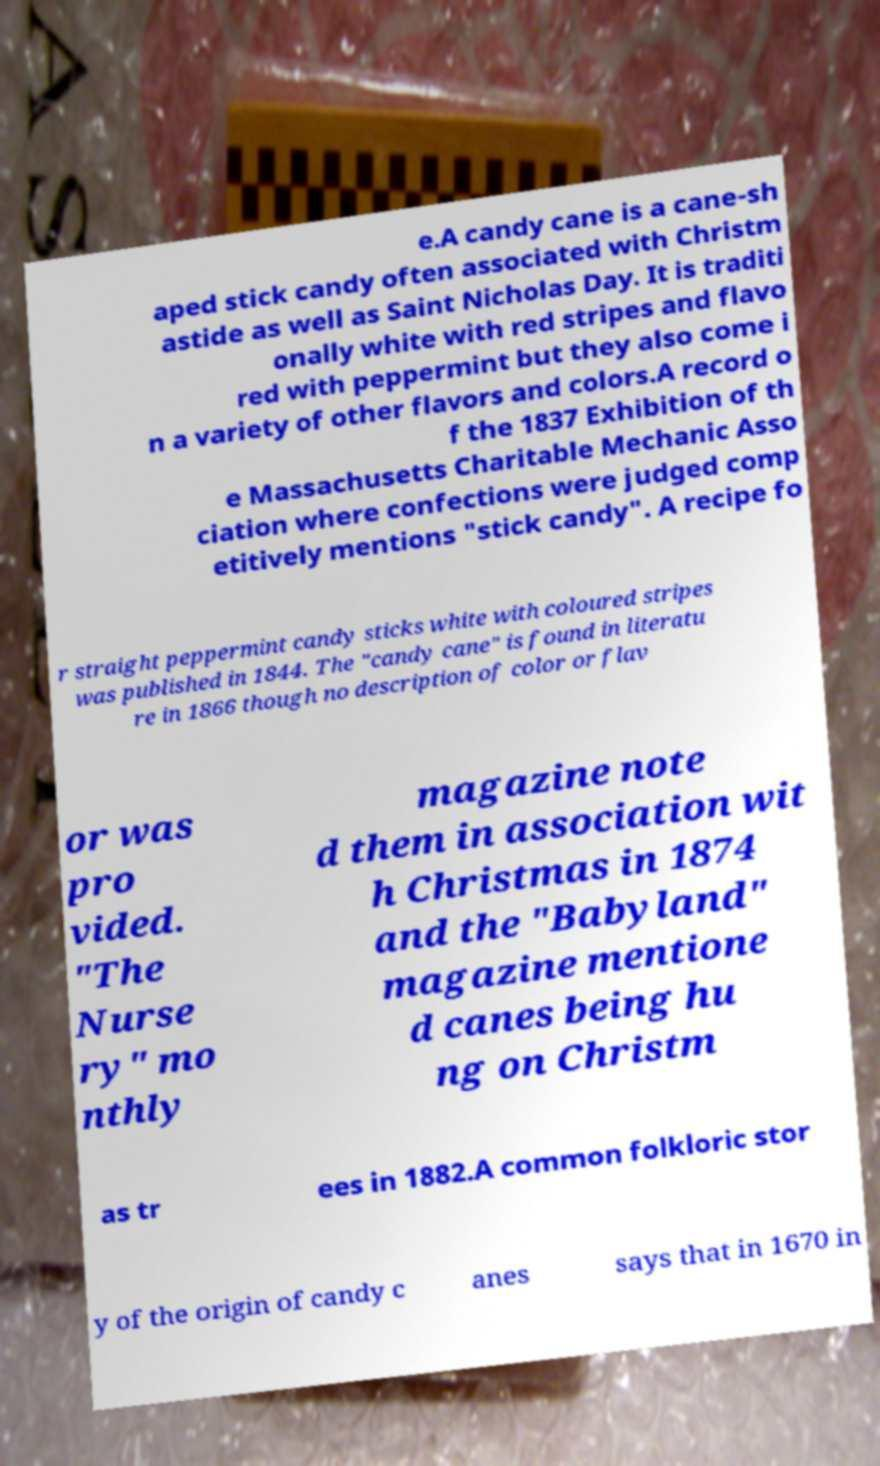For documentation purposes, I need the text within this image transcribed. Could you provide that? e.A candy cane is a cane-sh aped stick candy often associated with Christm astide as well as Saint Nicholas Day. It is traditi onally white with red stripes and flavo red with peppermint but they also come i n a variety of other flavors and colors.A record o f the 1837 Exhibition of th e Massachusetts Charitable Mechanic Asso ciation where confections were judged comp etitively mentions "stick candy". A recipe fo r straight peppermint candy sticks white with coloured stripes was published in 1844. The "candy cane" is found in literatu re in 1866 though no description of color or flav or was pro vided. "The Nurse ry" mo nthly magazine note d them in association wit h Christmas in 1874 and the "Babyland" magazine mentione d canes being hu ng on Christm as tr ees in 1882.A common folkloric stor y of the origin of candy c anes says that in 1670 in 